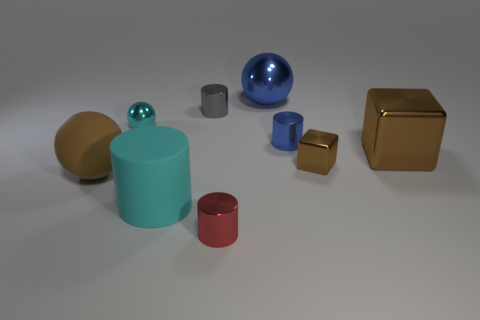Subtract 1 cylinders. How many cylinders are left? 3 Subtract all gray cylinders. How many cylinders are left? 3 Subtract all red cylinders. How many cylinders are left? 3 Add 1 gray blocks. How many objects exist? 10 Subtract all brown cylinders. Subtract all blue spheres. How many cylinders are left? 4 Subtract all cubes. How many objects are left? 7 Add 4 tiny shiny things. How many tiny shiny things exist? 9 Subtract 0 gray blocks. How many objects are left? 9 Subtract all metal objects. Subtract all brown rubber blocks. How many objects are left? 2 Add 2 cyan metal spheres. How many cyan metal spheres are left? 3 